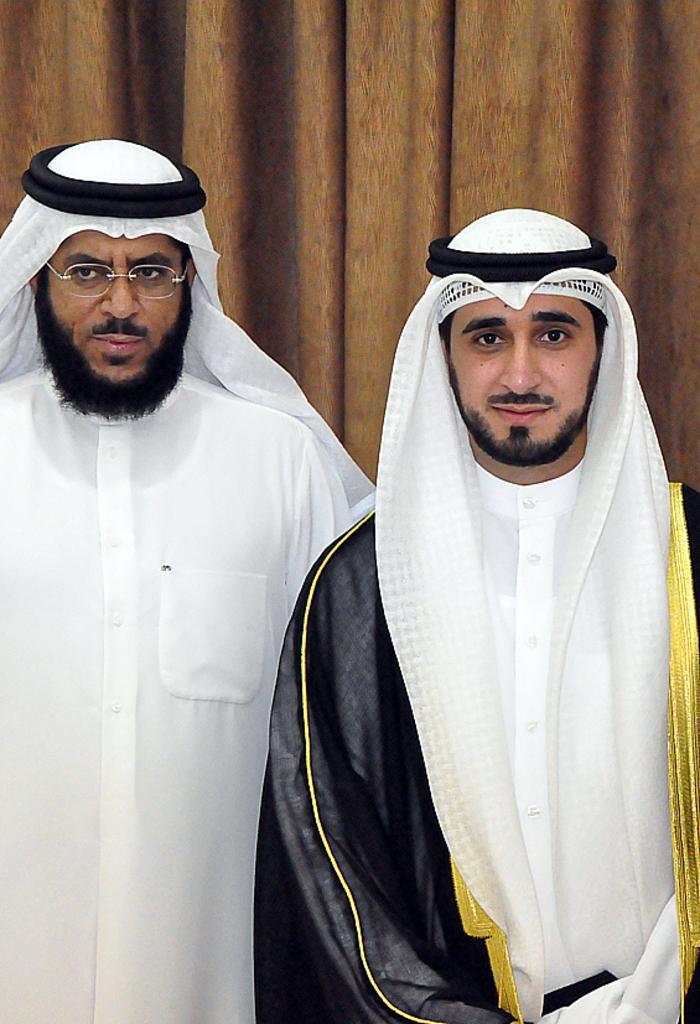How many sheikhs are present in the image? There are two sheikhs in the image. What are the sheikhs doing in the image? The sheikhs are standing. What type of window treatment is visible in the image? There are curtains visible in the image. Where is the dad in the image? There is no dad present in the image; it features two sheikhs. What type of lamp is visible on the sheikhs' heads in the image? There are no lamps visible on the sheikhs' heads in the image. 